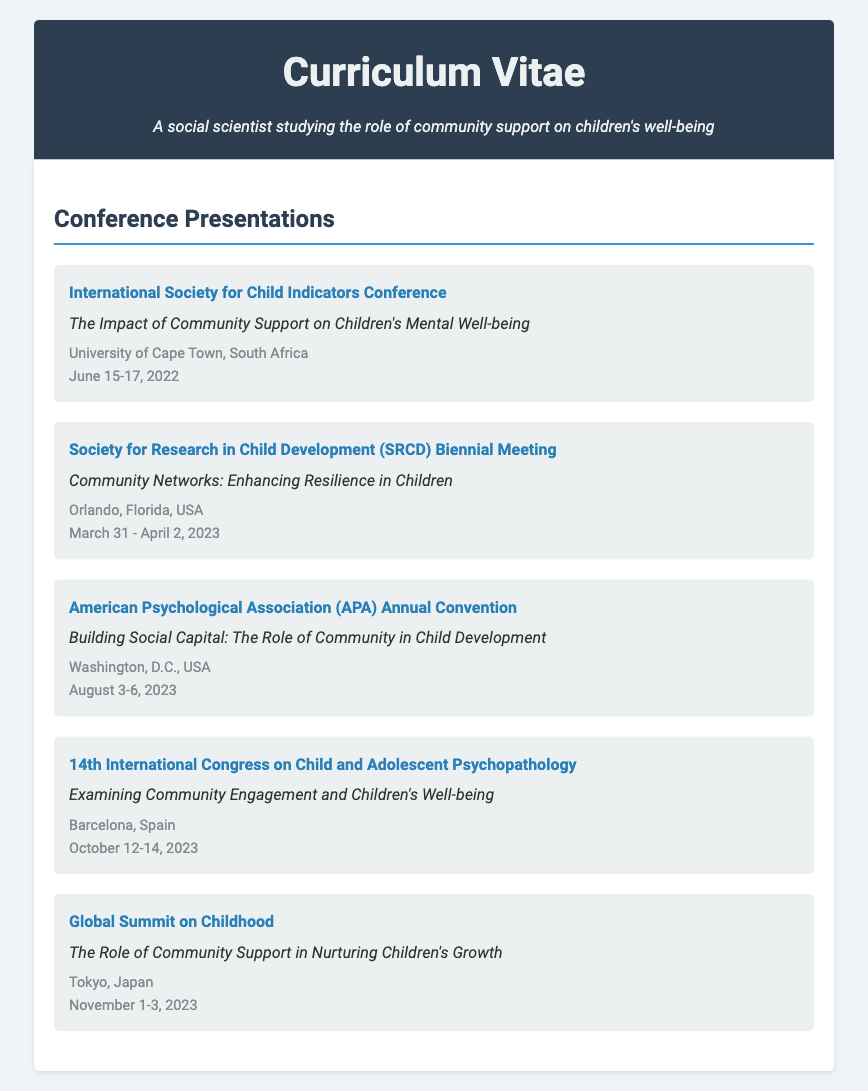What is the title of the presentation at the International Society for Child Indicators Conference? The title is listed under the conference details, which states, "The Impact of Community Support on Children's Mental Well-being."
Answer: The Impact of Community Support on Children's Mental Well-being When was the Society for Research in Child Development Biennial Meeting held? The dates of the conference are provided; it was held from March 31 to April 2, 2023.
Answer: March 31 - April 2, 2023 Where was the APA Annual Convention conducted? The location is specified in the document, which indicates it took place in Washington, D.C., USA.
Answer: Washington, D.C., USA How many conferences mentioned are scheduled for November 2023? By checking the document, it can be determined that there is one conference listed for that month, the Global Summit on Childhood.
Answer: 1 What is the main theme of the presentation at the 14th International Congress on Child and Adolescent Psychopathology? The theme is found in the presentation title, which is "Examining Community Engagement and Children's Well-being."
Answer: Examining Community Engagement and Children's Well-being What is the importance of attending these conferences as indicated in the document? The document highlights the importance of professional networking in the context of sharing research findings on community support and children's well-being.
Answer: Professional networking Which conference focuses on community support in nurturing children's growth? The document clearly states the title of the presentation at the Global Summit on Childhood addresses this topic.
Answer: The Role of Community Support in Nurturing Children's Growth List all the locations where the conferences took place. The document provides several locations: Cape Town, Orlando, Washington, Barcelona, and Tokyo.
Answer: Cape Town, Orlando, Washington, Barcelona, Tokyo 